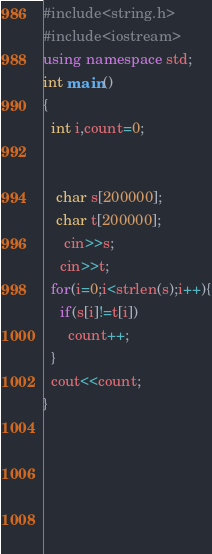<code> <loc_0><loc_0><loc_500><loc_500><_C++_>#include<string.h>
#include<iostream>
using namespace std;
int main()
{
  int i,count=0;
  
    
   char s[200000];
   char t[200000];
     cin>>s;
    cin>>t;
  for(i=0;i<strlen(s);i++){
    if(s[i]!=t[i])
      count++;
  }
  cout<<count;
}
  
  
    
      
  
    </code> 